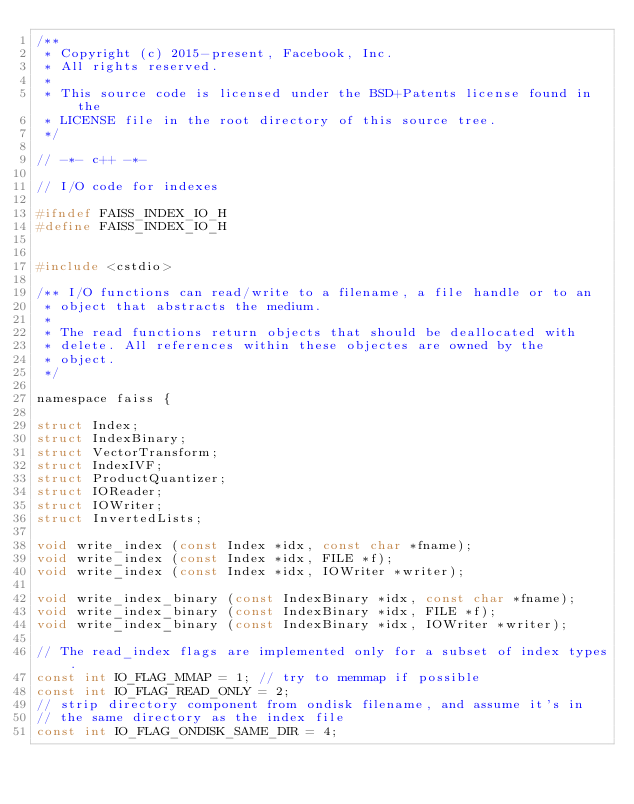<code> <loc_0><loc_0><loc_500><loc_500><_C_>/**
 * Copyright (c) 2015-present, Facebook, Inc.
 * All rights reserved.
 *
 * This source code is licensed under the BSD+Patents license found in the
 * LICENSE file in the root directory of this source tree.
 */

// -*- c++ -*-

// I/O code for indexes

#ifndef FAISS_INDEX_IO_H
#define FAISS_INDEX_IO_H


#include <cstdio>

/** I/O functions can read/write to a filename, a file handle or to an
 * object that abstracts the medium.
 *
 * The read functions return objects that should be deallocated with
 * delete. All references within these objectes are owned by the
 * object.
 */

namespace faiss {

struct Index;
struct IndexBinary;
struct VectorTransform;
struct IndexIVF;
struct ProductQuantizer;
struct IOReader;
struct IOWriter;
struct InvertedLists;

void write_index (const Index *idx, const char *fname);
void write_index (const Index *idx, FILE *f);
void write_index (const Index *idx, IOWriter *writer);

void write_index_binary (const IndexBinary *idx, const char *fname);
void write_index_binary (const IndexBinary *idx, FILE *f);
void write_index_binary (const IndexBinary *idx, IOWriter *writer);

// The read_index flags are implemented only for a subset of index types.
const int IO_FLAG_MMAP = 1; // try to memmap if possible
const int IO_FLAG_READ_ONLY = 2;
// strip directory component from ondisk filename, and assume it's in
// the same directory as the index file
const int IO_FLAG_ONDISK_SAME_DIR = 4;
</code> 